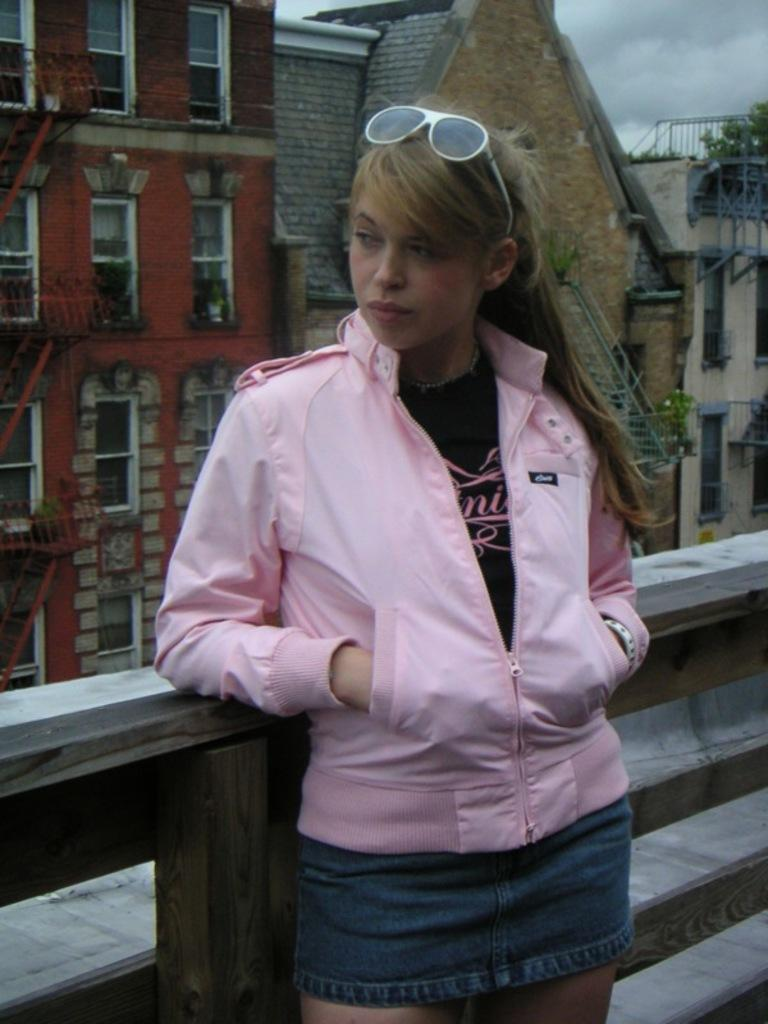Who is present in the image? There is a woman in the image. What is the woman doing in the image? The woman is standing near a rail. What can be seen in the background of the image? There are buildings and clouds visible in the sky in the background of the image. What type of hen can be seen in the grass in the image? There is no hen or grass present in the image. 